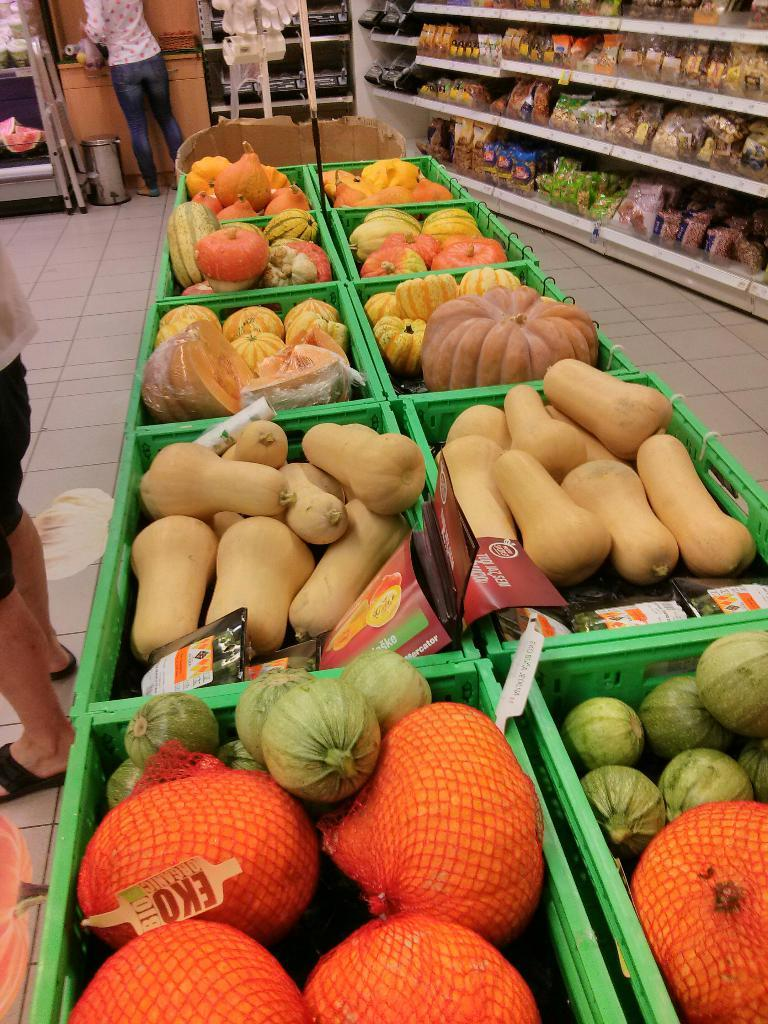What type of flooring is visible in the image? There are tiles in the image. What objects are present for storage in the image? There are baskets and racks in the image. What types of food items can be seen in the image? There are different types of vegetables in the image. How many people are in the image? There are two persons standing in the image. What is used for waste disposal in the image? There is a dustbin in the image. What is the background feature in the image? There is a wall in the image. What type of toothpaste is being used by the person in the image? There is no toothpaste present in the image. Where is the field located in the image? There is no field present in the image. 